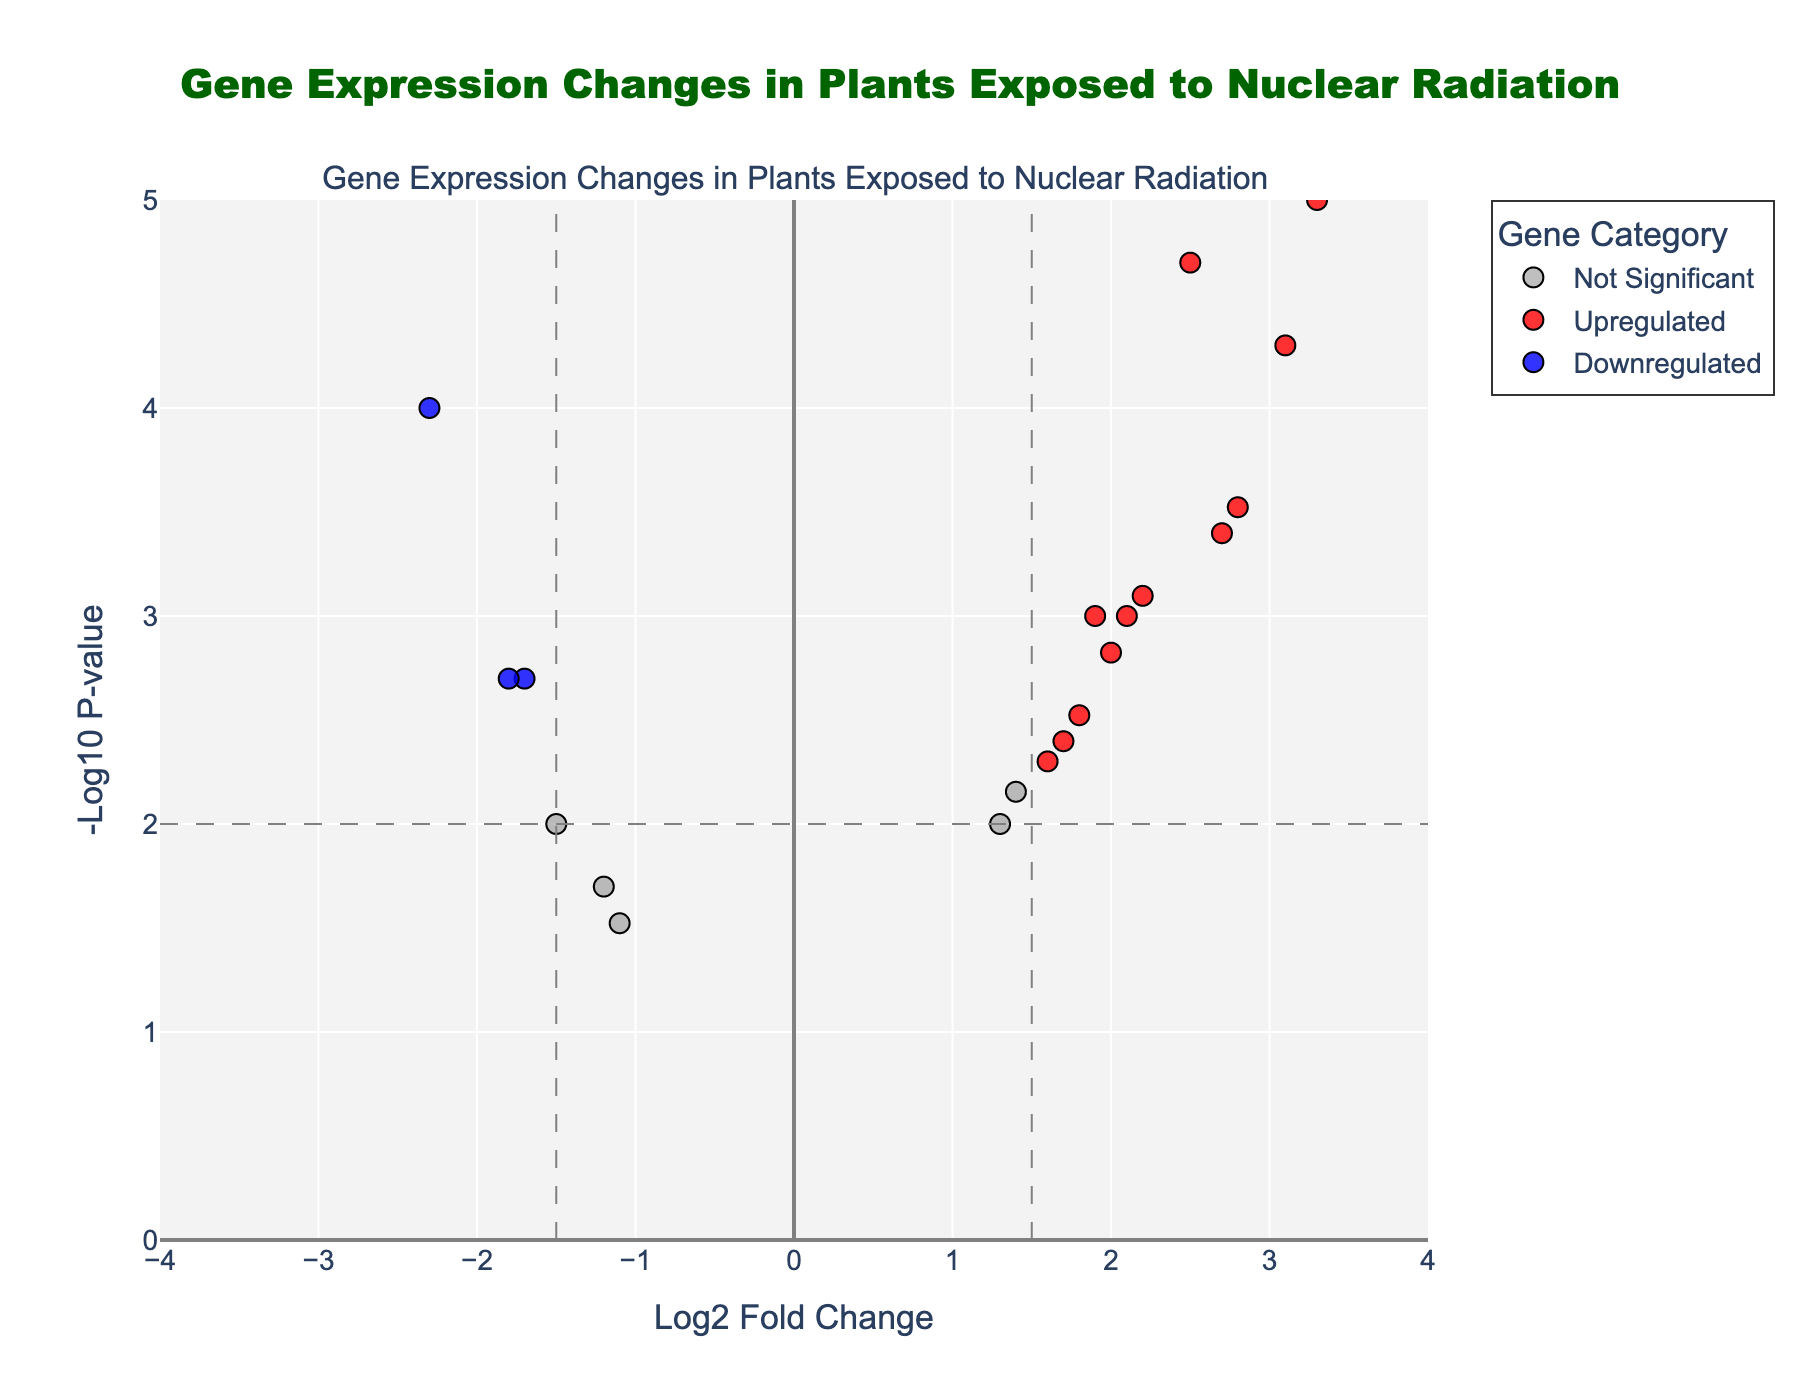Which gene is the most upregulated based on log2 fold change? Look at the genes with positive log2 fold change values and identify the one with the highest value. The gene with the highest log2 fold change is DDIT3, which shows a log2 fold change of 3.3.
Answer: DDIT3 How many genes are significantly upregulated? Identify genes categorized as "Upregulated" by checking those with a log2 fold change greater than 1.5 and a p-value less than 0.01. Counting from the plot, there are 7 such genes: CDKN1A, GADD45A, TP53, BRCA1, PCNA, DDIT3, and HSP70.
Answer: 7 What is the color used for downregulated genes? Identify the color associated with the data points categorized as "Downregulated." The color for downregulated genes is blue.
Answer: blue Which gene has the lowest p-value, and what is its value? Find the gene with the smallest p-value by examining the vertical positioning (highest y-axis) on the plot. DDIT3 stands out as having the lowest p-value of 0.00001.
Answer: DDIT3, 0.00001 Compare the log2 fold change of RAD51 and BAX genes. Which one is higher? Check the log2 fold change values for RAD51 and BAX. For RAD51, it is -2.3, and for BAX, it is 2.1. Since 2.1 is greater than -2.3, BAX has a higher log2 fold change.
Answer: BAX What p-value threshold is used to determine significance in this plot? Look at the y-axis threshold line indicated by the horizontal dash line to identify the p-value cutoff. This line is at -log10(0.01), which converts back to a p-value threshold of 0.01.
Answer: 0.01 How many genes show a log2 fold change less than -1.5 but are not downregulated? Identify genes with a log2 fold change less than -1.5 but categorized as "Not Significant" rather than "Downregulated." From the plot, only PARP1 fits this description.
Answer: 1 What is the title of the plot? Look at the text displayed at the top center of the plot in the largest font size. The title is "Gene Expression Changes in Plants Exposed to Nuclear Radiation."
Answer: Gene Expression Changes in Plants Exposed to Nuclear Radiation Is there a relationship between the direction of gene regulation (upregulated or downregulated) and their p-values? Compare the vertical distribution (-log10 p-value) of upregulated (red dots) versus downregulated (blue dots) genes. Generally, both upregulated and downregulated genes are distributed across a similar range of p-values, indicating no obvious relationship.
Answer: No Which genes have a log2 fold change exactly equal to 2.0? Identify the data points positioned at 2.0 on the x-axis. In this case, PCNA is the gene with a log2 fold change of exactly 2.0.
Answer: PCNA 